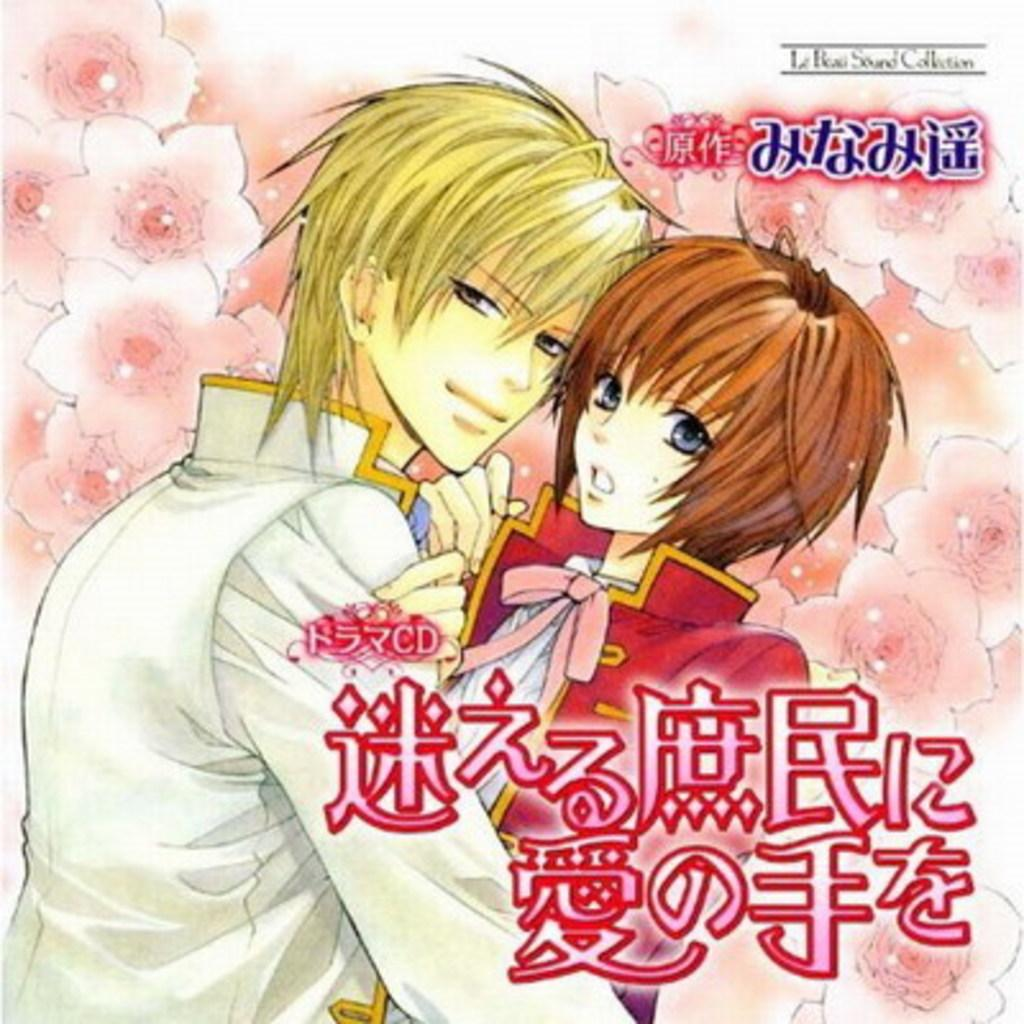What type of characters are depicted in the image? There are cartoon images of a boy and a girl in the image. What other elements can be seen in the image? There are cartoon images of flowers in the image. Are there any words or phrases written on the image? Yes, texts are written on the image. How many servants are present in the image? There are no servants depicted in the image; it features cartoon images of a boy, a girl, and flowers. What is the size of the root in the image? There is no root present in the image; it features cartoon images of a boy, a girl, and flowers. 